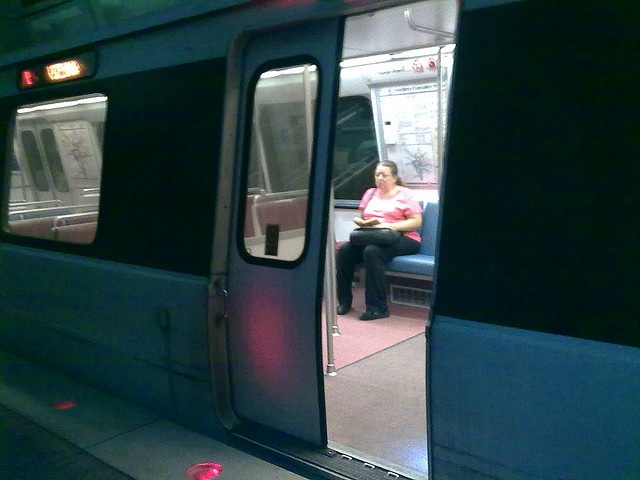Describe the objects in this image and their specific colors. I can see train in black, blue, darkgray, and darkblue tones, people in black, white, lightpink, and gray tones, chair in black, gray, and blue tones, handbag in black, gray, purple, and darkblue tones, and book in black, ivory, olive, gray, and lightpink tones in this image. 